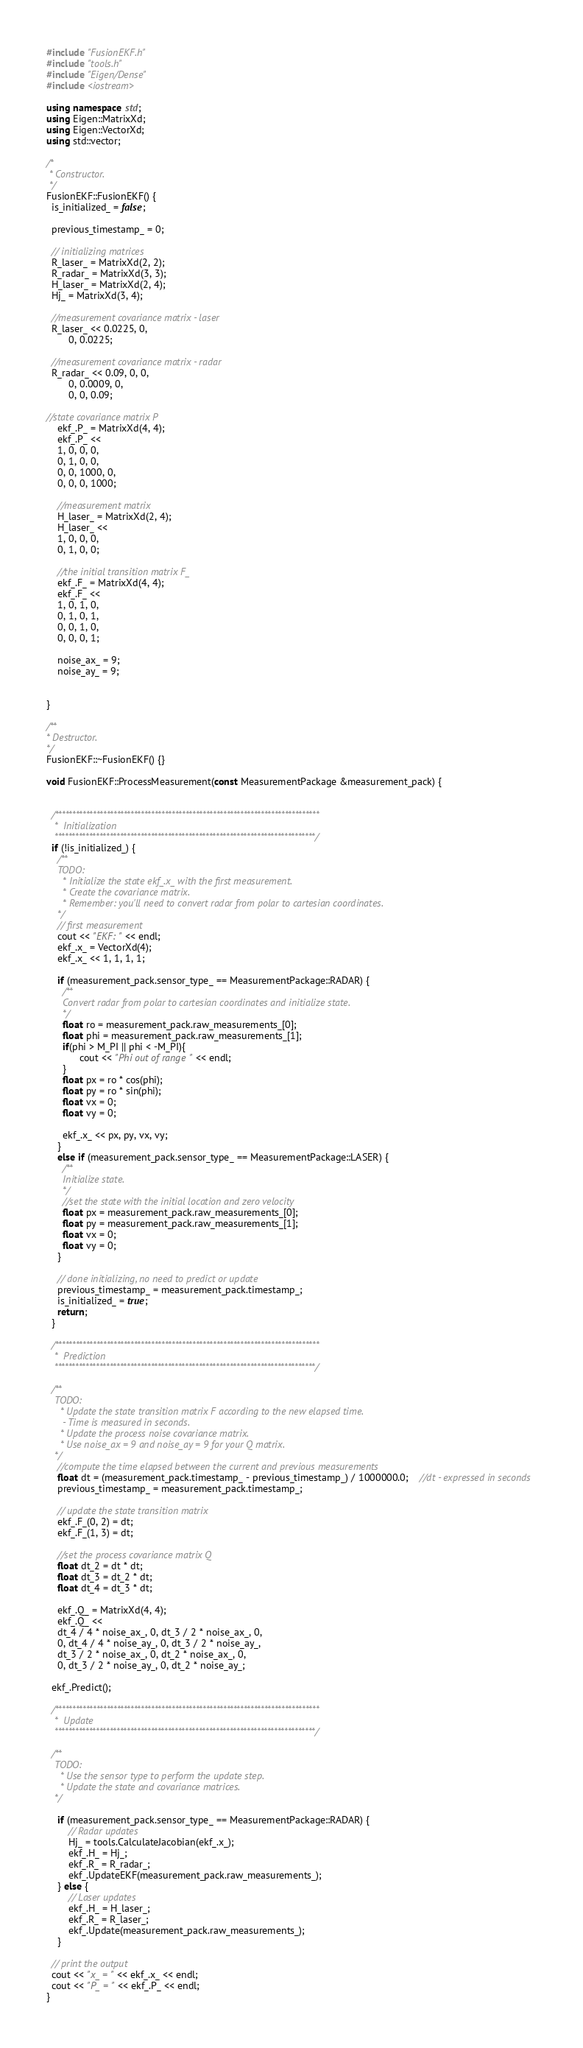<code> <loc_0><loc_0><loc_500><loc_500><_C++_>#include "FusionEKF.h"
#include "tools.h"
#include "Eigen/Dense"
#include <iostream>

using namespace std;
using Eigen::MatrixXd;
using Eigen::VectorXd;
using std::vector;

/*
 * Constructor.
 */
FusionEKF::FusionEKF() {
  is_initialized_ = false;

  previous_timestamp_ = 0;

  // initializing matrices
  R_laser_ = MatrixXd(2, 2);
  R_radar_ = MatrixXd(3, 3);
  H_laser_ = MatrixXd(2, 4);
  Hj_ = MatrixXd(3, 4);

  //measurement covariance matrix - laser
  R_laser_ << 0.0225, 0,
        0, 0.0225;

  //measurement covariance matrix - radar
  R_radar_ << 0.09, 0, 0,
        0, 0.0009, 0,
        0, 0, 0.09;

//state covariance matrix P
    ekf_.P_ = MatrixXd(4, 4);
    ekf_.P_ <<
    1, 0, 0, 0,
    0, 1, 0, 0,
    0, 0, 1000, 0,
    0, 0, 0, 1000;
    
    //measurement matrix
    H_laser_ = MatrixXd(2, 4);
    H_laser_ <<
    1, 0, 0, 0,
    0, 1, 0, 0;
    
    //the initial transition matrix F_
    ekf_.F_ = MatrixXd(4, 4);
    ekf_.F_ <<
    1, 0, 1, 0,
    0, 1, 0, 1,
    0, 0, 1, 0,
    0, 0, 0, 1;
    
    noise_ax_ = 9;
    noise_ay_ = 9;


}

/**
* Destructor.
*/
FusionEKF::~FusionEKF() {}

void FusionEKF::ProcessMeasurement(const MeasurementPackage &measurement_pack) {


  /*****************************************************************************
   *  Initialization
   ****************************************************************************/
  if (!is_initialized_) {
    /**
    TODO:
      * Initialize the state ekf_.x_ with the first measurement.
      * Create the covariance matrix.
      * Remember: you'll need to convert radar from polar to cartesian coordinates.
    */
    // first measurement
    cout << "EKF: " << endl;
    ekf_.x_ = VectorXd(4);
    ekf_.x_ << 1, 1, 1, 1;

    if (measurement_pack.sensor_type_ == MeasurementPackage::RADAR) {
      /**
      Convert radar from polar to cartesian coordinates and initialize state.
      */
      float ro = measurement_pack.raw_measurements_[0];
      float phi = measurement_pack.raw_measurements_[1];
      if(phi > M_PI || phi < -M_PI){
            cout << "Phi out of range" << endl;
      }
      float px = ro * cos(phi);
      float py = ro * sin(phi);
      float vx = 0;
      float vy = 0;

      ekf_.x_ << px, py, vx, vy;
    }
    else if (measurement_pack.sensor_type_ == MeasurementPackage::LASER) {
      /**
      Initialize state.
      */
      //set the state with the initial location and zero velocity
      float px = measurement_pack.raw_measurements_[0];
      float py = measurement_pack.raw_measurements_[1];
      float vx = 0;
      float vy = 0;
    }

    // done initializing, no need to predict or update
    previous_timestamp_ = measurement_pack.timestamp_;
    is_initialized_ = true;
    return;
  }

  /*****************************************************************************
   *  Prediction
   ****************************************************************************/

  /**
   TODO:
     * Update the state transition matrix F according to the new elapsed time.
      - Time is measured in seconds.
     * Update the process noise covariance matrix.
     * Use noise_ax = 9 and noise_ay = 9 for your Q matrix.
   */
    //compute the time elapsed between the current and previous measurements
    float dt = (measurement_pack.timestamp_ - previous_timestamp_) / 1000000.0;    //dt - expressed in seconds
    previous_timestamp_ = measurement_pack.timestamp_;
    
    // update the state transition matrix
    ekf_.F_(0, 2) = dt;
    ekf_.F_(1, 3) = dt;
    
    //set the process covariance matrix Q
    float dt_2 = dt * dt;
    float dt_3 = dt_2 * dt;
    float dt_4 = dt_3 * dt;
    
    ekf_.Q_ = MatrixXd(4, 4);
    ekf_.Q_ <<
    dt_4 / 4 * noise_ax_, 0, dt_3 / 2 * noise_ax_, 0,
    0, dt_4 / 4 * noise_ay_, 0, dt_3 / 2 * noise_ay_,
    dt_3 / 2 * noise_ax_, 0, dt_2 * noise_ax_, 0,
    0, dt_3 / 2 * noise_ay_, 0, dt_2 * noise_ay_;

  ekf_.Predict();

  /*****************************************************************************
   *  Update
   ****************************************************************************/

  /**
   TODO:
     * Use the sensor type to perform the update step.
     * Update the state and covariance matrices.
   */

    if (measurement_pack.sensor_type_ == MeasurementPackage::RADAR) {
        // Radar updates
        Hj_ = tools.CalculateJacobian(ekf_.x_);
        ekf_.H_ = Hj_;
        ekf_.R_ = R_radar_;
        ekf_.UpdateEKF(measurement_pack.raw_measurements_);
    } else {
        // Laser updates
        ekf_.H_ = H_laser_;
        ekf_.R_ = R_laser_;
        ekf_.Update(measurement_pack.raw_measurements_);
    }

  // print the output
  cout << "x_ = " << ekf_.x_ << endl;
  cout << "P_ = " << ekf_.P_ << endl;
}
</code> 